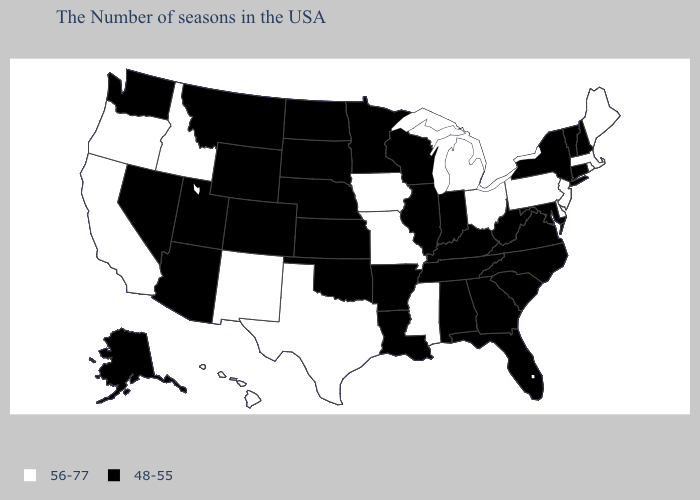What is the value of South Dakota?
Concise answer only. 48-55. Does Montana have the same value as California?
Be succinct. No. What is the value of Maryland?
Keep it brief. 48-55. Which states hav the highest value in the Northeast?
Short answer required. Maine, Massachusetts, Rhode Island, New Jersey, Pennsylvania. Name the states that have a value in the range 48-55?
Write a very short answer. New Hampshire, Vermont, Connecticut, New York, Maryland, Virginia, North Carolina, South Carolina, West Virginia, Florida, Georgia, Kentucky, Indiana, Alabama, Tennessee, Wisconsin, Illinois, Louisiana, Arkansas, Minnesota, Kansas, Nebraska, Oklahoma, South Dakota, North Dakota, Wyoming, Colorado, Utah, Montana, Arizona, Nevada, Washington, Alaska. What is the highest value in states that border Kansas?
Short answer required. 56-77. Which states have the lowest value in the West?
Short answer required. Wyoming, Colorado, Utah, Montana, Arizona, Nevada, Washington, Alaska. Name the states that have a value in the range 56-77?
Keep it brief. Maine, Massachusetts, Rhode Island, New Jersey, Delaware, Pennsylvania, Ohio, Michigan, Mississippi, Missouri, Iowa, Texas, New Mexico, Idaho, California, Oregon, Hawaii. Name the states that have a value in the range 48-55?
Keep it brief. New Hampshire, Vermont, Connecticut, New York, Maryland, Virginia, North Carolina, South Carolina, West Virginia, Florida, Georgia, Kentucky, Indiana, Alabama, Tennessee, Wisconsin, Illinois, Louisiana, Arkansas, Minnesota, Kansas, Nebraska, Oklahoma, South Dakota, North Dakota, Wyoming, Colorado, Utah, Montana, Arizona, Nevada, Washington, Alaska. How many symbols are there in the legend?
Be succinct. 2. What is the lowest value in the West?
Write a very short answer. 48-55. What is the value of Rhode Island?
Keep it brief. 56-77. What is the value of Montana?
Give a very brief answer. 48-55. Does South Carolina have the lowest value in the USA?
Concise answer only. Yes. Among the states that border New Mexico , does Texas have the lowest value?
Be succinct. No. 